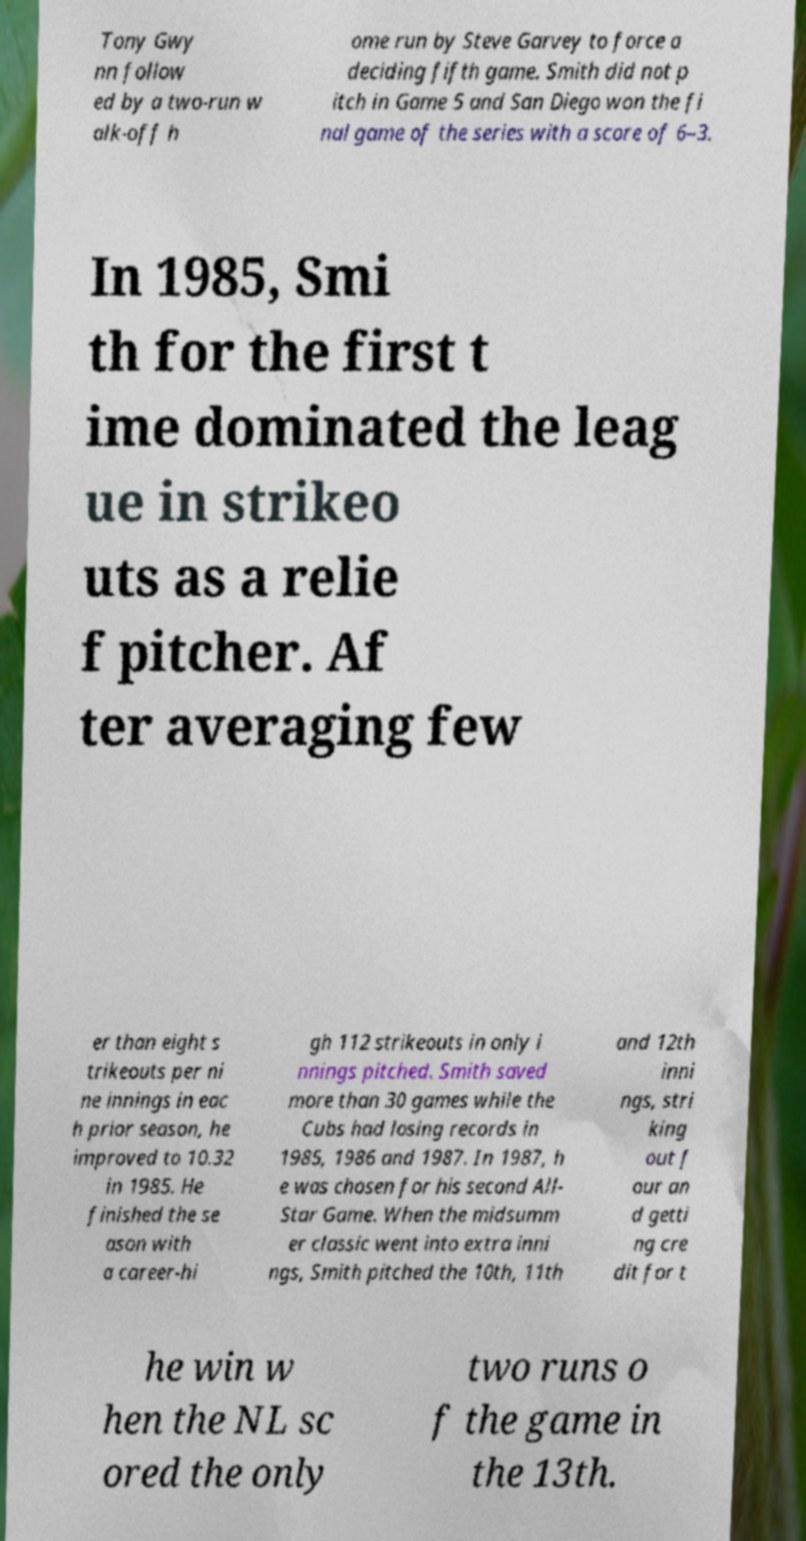For documentation purposes, I need the text within this image transcribed. Could you provide that? Tony Gwy nn follow ed by a two-run w alk-off h ome run by Steve Garvey to force a deciding fifth game. Smith did not p itch in Game 5 and San Diego won the fi nal game of the series with a score of 6–3. In 1985, Smi th for the first t ime dominated the leag ue in strikeo uts as a relie f pitcher. Af ter averaging few er than eight s trikeouts per ni ne innings in eac h prior season, he improved to 10.32 in 1985. He finished the se ason with a career-hi gh 112 strikeouts in only i nnings pitched. Smith saved more than 30 games while the Cubs had losing records in 1985, 1986 and 1987. In 1987, h e was chosen for his second All- Star Game. When the midsumm er classic went into extra inni ngs, Smith pitched the 10th, 11th and 12th inni ngs, stri king out f our an d getti ng cre dit for t he win w hen the NL sc ored the only two runs o f the game in the 13th. 